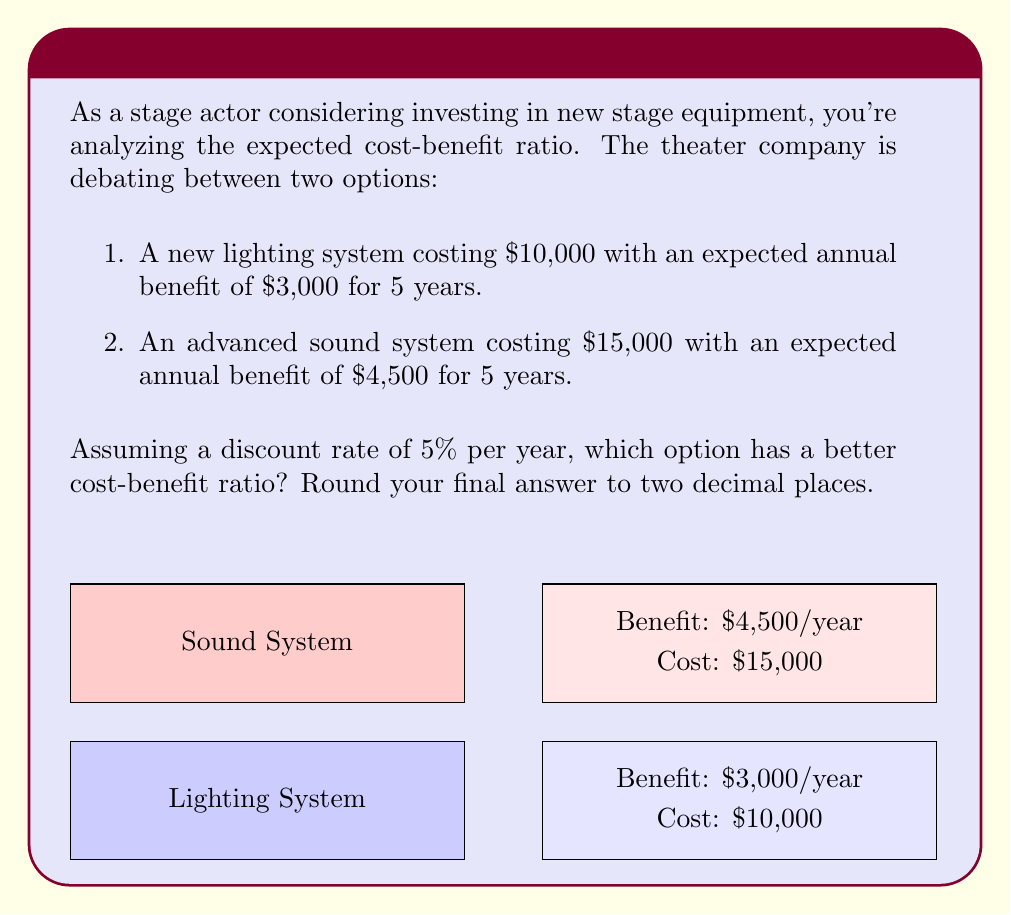What is the answer to this math problem? Let's approach this step-by-step:

1) First, we need to calculate the Present Value (PV) of the benefits for each option using the formula:

   $$PV = \sum_{t=1}^{n} \frac{C_t}{(1+r)^t}$$

   Where $C_t$ is the cash flow at time t, r is the discount rate, and n is the number of periods.

2) For the lighting system:
   $$PV_{benefits} = \sum_{t=1}^{5} \frac{3000}{(1.05)^t} = 3000 * (\frac{1-(1.05)^{-5}}{0.05}) = 12,997.89$$

3) For the sound system:
   $$PV_{benefits} = \sum_{t=1}^{5} \frac{4500}{(1.05)^t} = 4500 * (\frac{1-(1.05)^{-5}}{0.05}) = 19,496.84$$

4) Now, we calculate the cost-benefit ratio for each option:

   Lighting system: $\frac{12,997.89}{10,000} = 1.30$

   Sound system: $\frac{19,496.84}{15,000} = 1.30$

5) Both systems have the same cost-benefit ratio when rounded to two decimal places.
Answer: 1.30 (both options have the same ratio) 